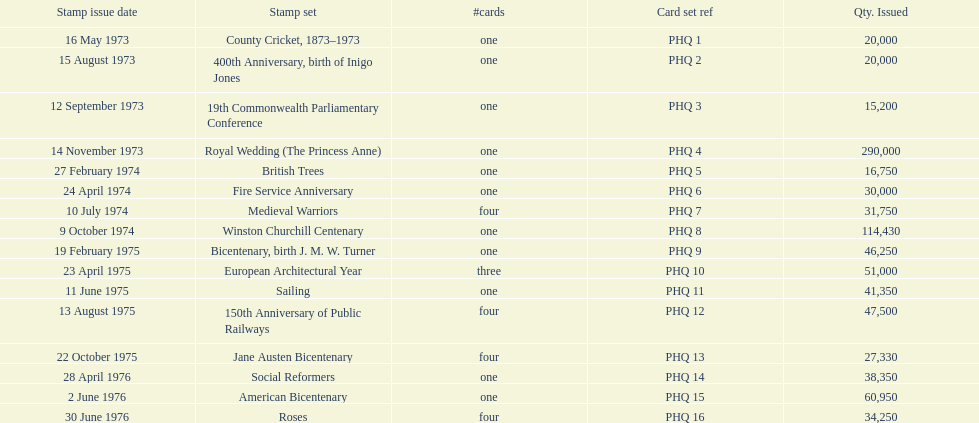Which stamp kit consisted of only three cards in the compilation? European Architectural Year. 